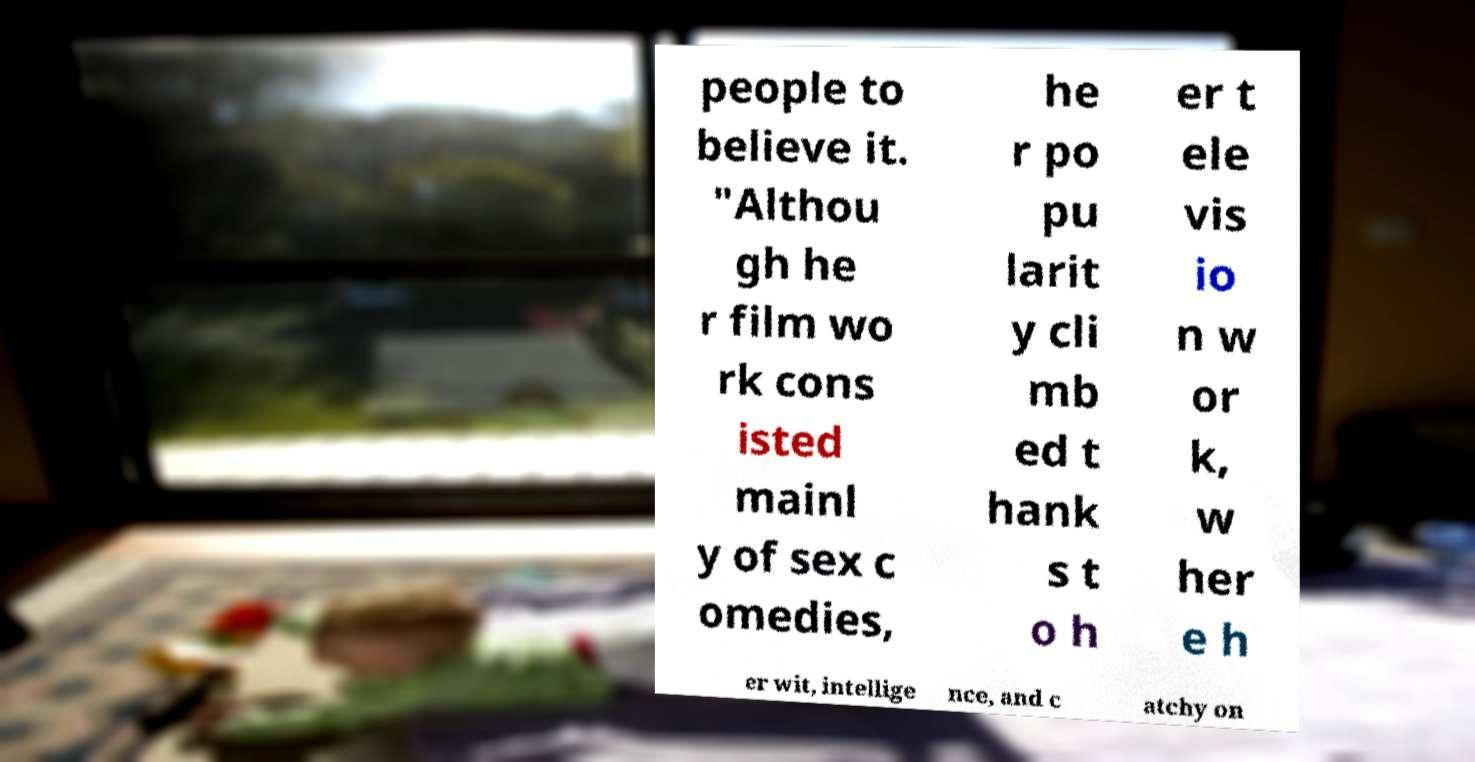Can you read and provide the text displayed in the image?This photo seems to have some interesting text. Can you extract and type it out for me? people to believe it. "Althou gh he r film wo rk cons isted mainl y of sex c omedies, he r po pu larit y cli mb ed t hank s t o h er t ele vis io n w or k, w her e h er wit, intellige nce, and c atchy on 